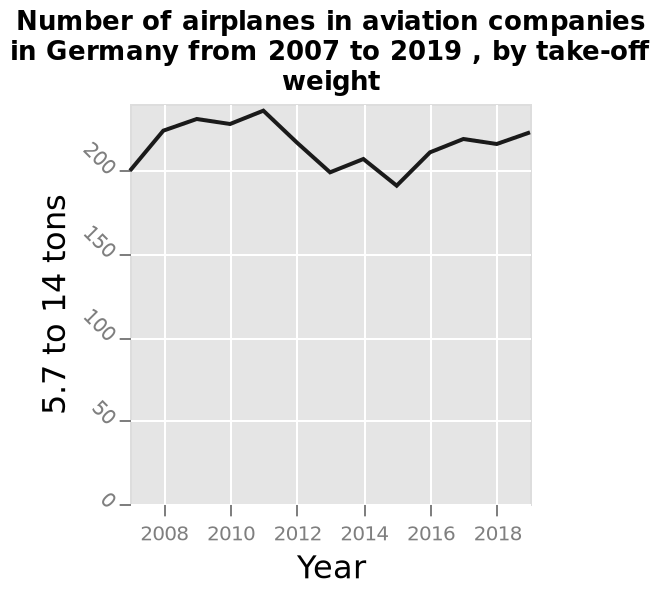<image>
Offer a thorough analysis of the image. The frequency of planes with a take of weight of 5.7 to 14 tons tens to be around the 200 mark each year, sometimes dipping slightly below and sometimes rising a bit above. There appears to be no consistent trend over the 10 years depicted on this graph but it is possible the the number is projected to increase in the future. What can be said about the weight of German aircraft during takeoff? It appears that the weight of German aircraft during takeoff does not vary significantly. 